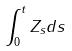<formula> <loc_0><loc_0><loc_500><loc_500>\int _ { 0 } ^ { t } Z _ { s } d s</formula> 